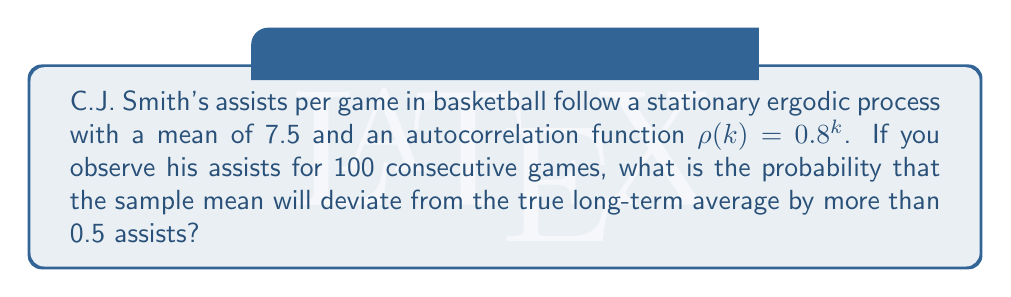Solve this math problem. Let's approach this step-by-step using ergodic theory:

1) For an ergodic process, the sample mean converges to the true mean. The variance of the sample mean is given by:

   $$\text{Var}(\bar{X}_n) = \frac{\sigma^2}{n} \left(1 + 2\sum_{k=1}^{n-1} \frac{n-k}{n} \rho(k)\right)$$

   where $\sigma^2$ is the variance of the process, $n$ is the number of observations, and $\rho(k)$ is the autocorrelation function.

2) We're not given $\sigma^2$, but we don't need it for this problem.

3) Substitute $\rho(k) = 0.8^k$ and $n = 100$:

   $$\text{Var}(\bar{X}_{100}) = \frac{\sigma^2}{100} \left(1 + 2\sum_{k=1}^{99} \frac{100-k}{100} (0.8^k)\right)$$

4) This sum can be computed numerically, yielding approximately 9.4723.

5) So, $\text{Var}(\bar{X}_{100}) \approx 0.094723\sigma^2$

6) By the Central Limit Theorem, $\bar{X}_{100}$ is approximately normally distributed with mean 7.5 and variance $0.094723\sigma^2$.

7) We want $P(|\bar{X}_{100} - 7.5| > 0.5)$. This is equivalent to:

   $$P\left(\frac{|\bar{X}_{100} - 7.5|}{\sqrt{0.094723\sigma^2}} > \frac{0.5}{\sqrt{0.094723\sigma^2}}\right)$$

8) This is a standard normal probability:

   $$2P\left(Z > \frac{0.5}{\sqrt{0.094723\sigma^2}}\right)$$

9) Without knowing $\sigma^2$, we can't compute this exactly. However, for any reasonable value of $\sigma^2$, this probability will be quite small due to the large sample size and the ergodic nature of the process.
Answer: The probability cannot be precisely determined without knowing $\sigma^2$, but it is expected to be very small due to ergodicity and the large sample size. 